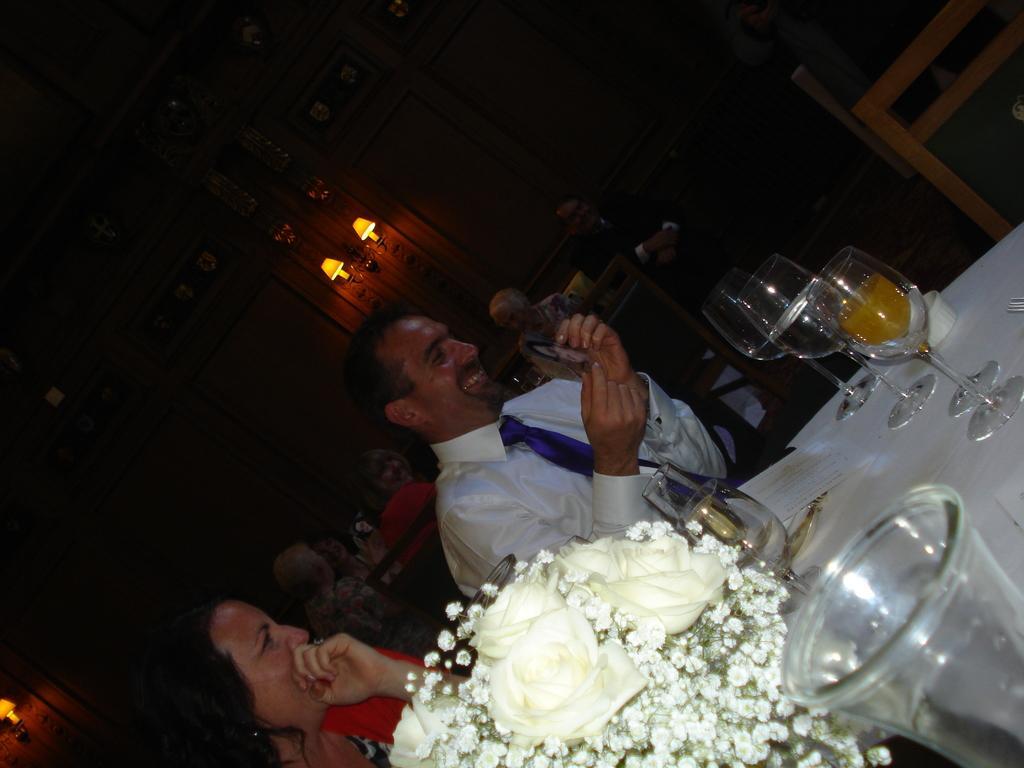How would you summarize this image in a sentence or two? In this image, we can see few people are sitting on the chairs. Here a person is smiling and holding an object. On the right side bottom of the image, we can see table, flowers, glasses and few things. Background we can see wall and lights. 